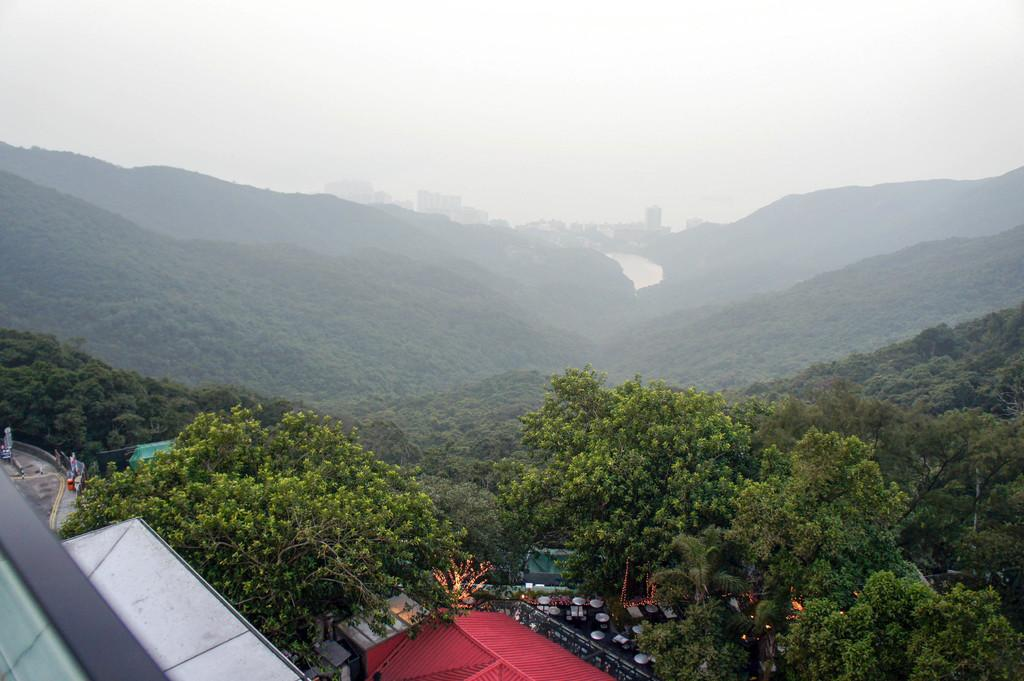What type of attraction is present in the image? There is no attraction present in the image; it features trees, buildings, hills, and a cloudy sky. Can you identify any structures that might be considered buildings in the image? Yes, there are buildings in the image. What type of natural feature can be seen in the image? There are trees and hills visible in the image. How would you describe the weather in the image? The sky is cloudy in the image, which suggests a potentially overcast or rainy day. What type of parent is depicted in the image? There is no parent present in the image; it features trees, buildings, hills, and a cloudy sky. What is the value of the attraction in the image? There is no attraction present in the image, so it is not possible to determine its value. 